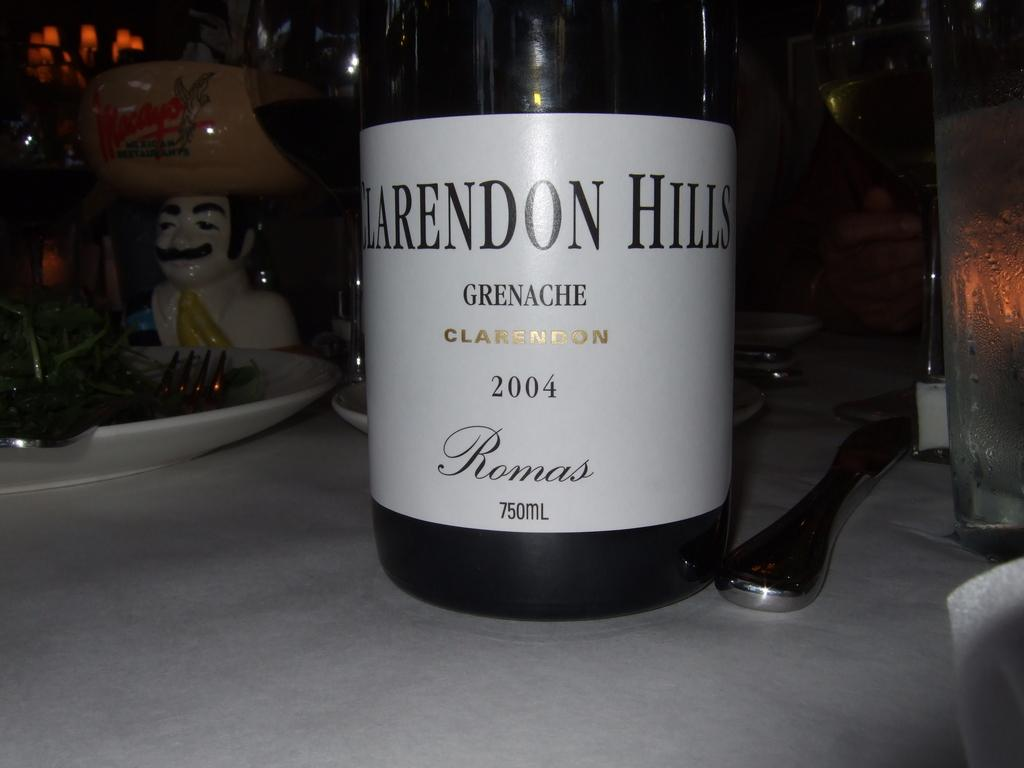What objects can be seen on the table in the image? There are bottles, plates, a knife, forks, and a toy on the table in the image. What type of utensils are present on the table? There is a knife and forks on the table. What is the background of the image like? The background of the image is dark. How does the crowd interact with the toy in the image? There is no crowd present in the image, so it is not possible to answer how they might interact with the toy. What memories does the rabbit have of the event in the image? There is no rabbit present in the image, so it is not possible to answer how it might remember any events. 